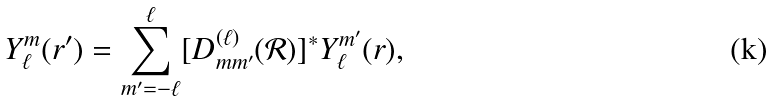<formula> <loc_0><loc_0><loc_500><loc_500>Y _ { \ell } ^ { m } ( { r } ^ { \prime } ) = \sum _ { m ^ { \prime } = - \ell } ^ { \ell } [ D _ { m m ^ { \prime } } ^ { ( \ell ) } ( { \mathcal { R } } ) ] ^ { * } Y _ { \ell } ^ { m ^ { \prime } } ( { r } ) ,</formula> 